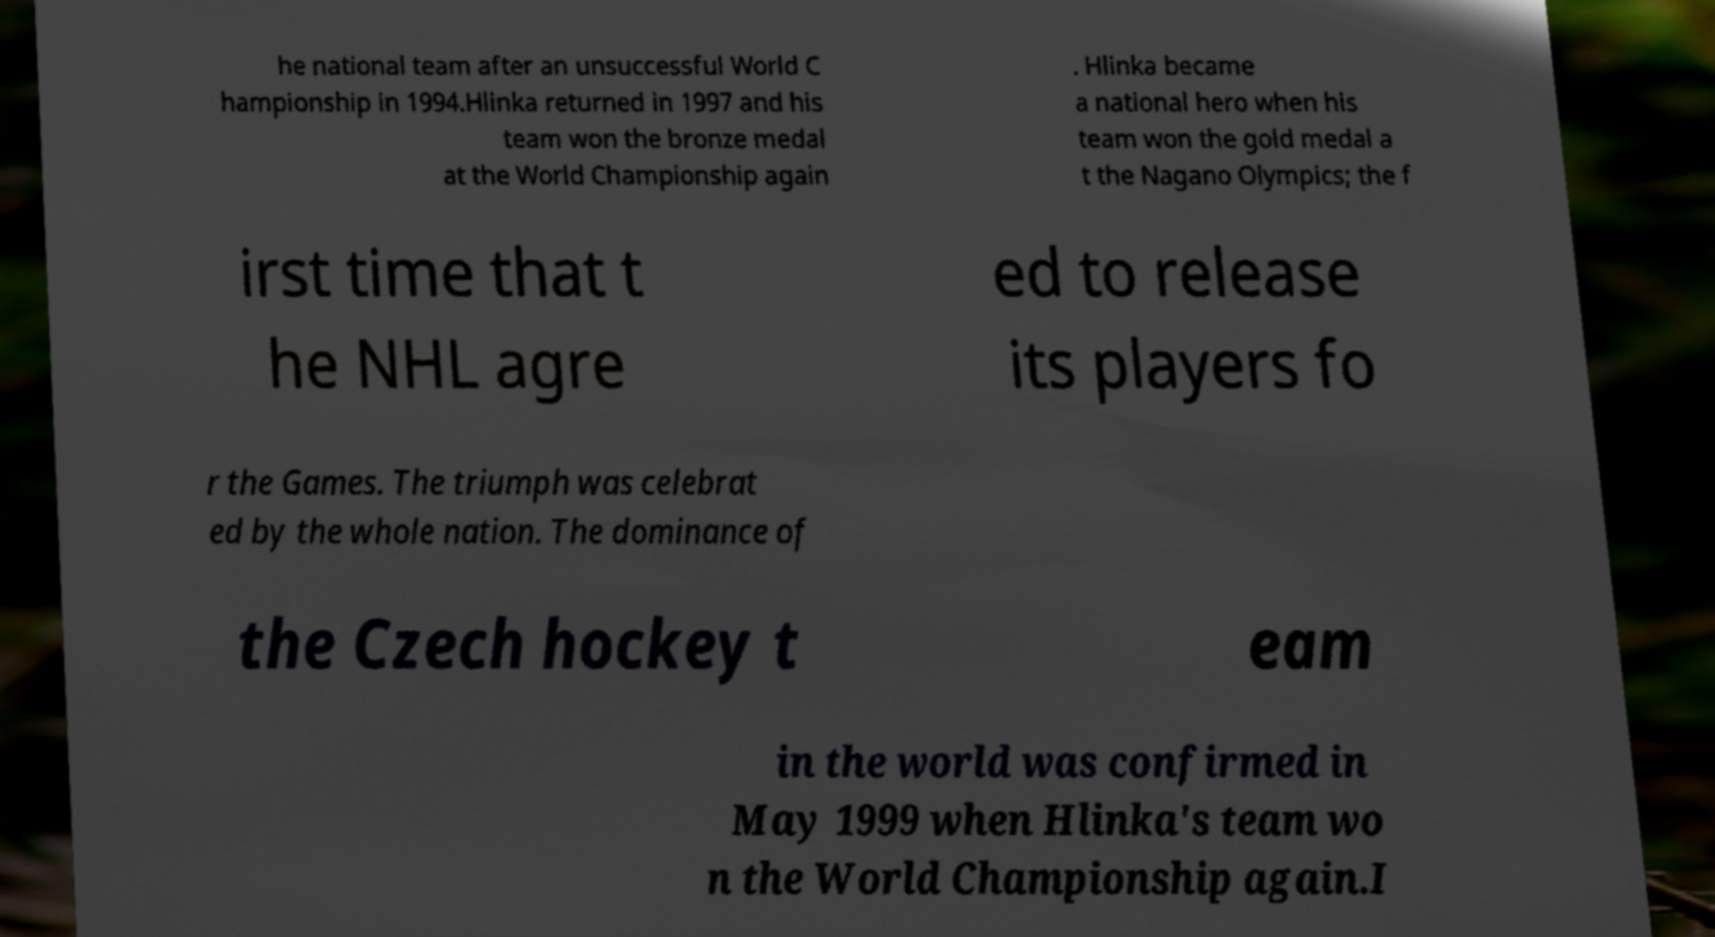Please identify and transcribe the text found in this image. he national team after an unsuccessful World C hampionship in 1994.Hlinka returned in 1997 and his team won the bronze medal at the World Championship again . Hlinka became a national hero when his team won the gold medal a t the Nagano Olympics; the f irst time that t he NHL agre ed to release its players fo r the Games. The triumph was celebrat ed by the whole nation. The dominance of the Czech hockey t eam in the world was confirmed in May 1999 when Hlinka's team wo n the World Championship again.I 